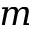<formula> <loc_0><loc_0><loc_500><loc_500>m</formula> 